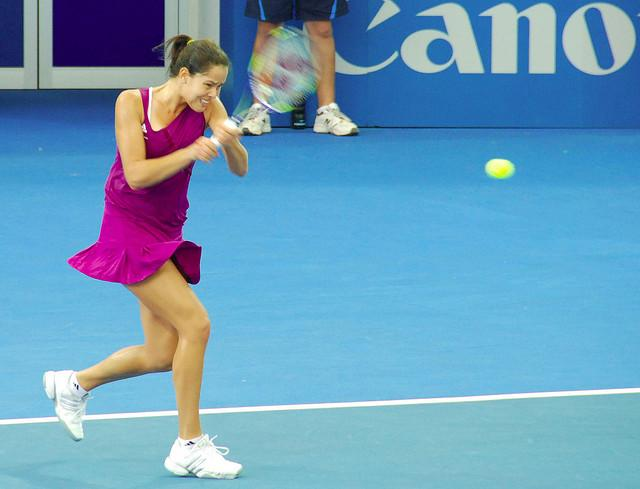What is the most likely reason for the word appearing on the wall behind the athlete? advertisement 